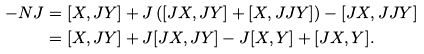<formula> <loc_0><loc_0><loc_500><loc_500>- N J = & \ [ X , J Y ] + J \left ( [ J X , J Y ] + [ X , J J Y ] \right ) - [ J X , J J Y ] \\ = & \ [ X , J Y ] + J [ J X , J Y ] - J [ X , Y ] + [ J X , Y ] .</formula> 